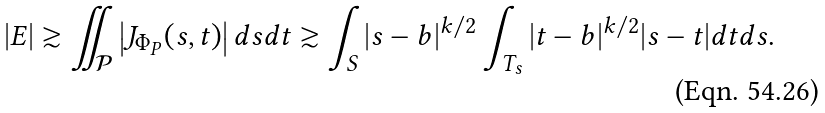Convert formula to latex. <formula><loc_0><loc_0><loc_500><loc_500>| E | \gtrsim \iint _ { \mathcal { P } } \left | J _ { \Phi _ { P } } ( s , t ) \right | d s d t \gtrsim \int _ { S } | s - b | ^ { k / 2 } \int _ { T _ { s } } | t - b | ^ { k / 2 } | s - t | d t d s .</formula> 